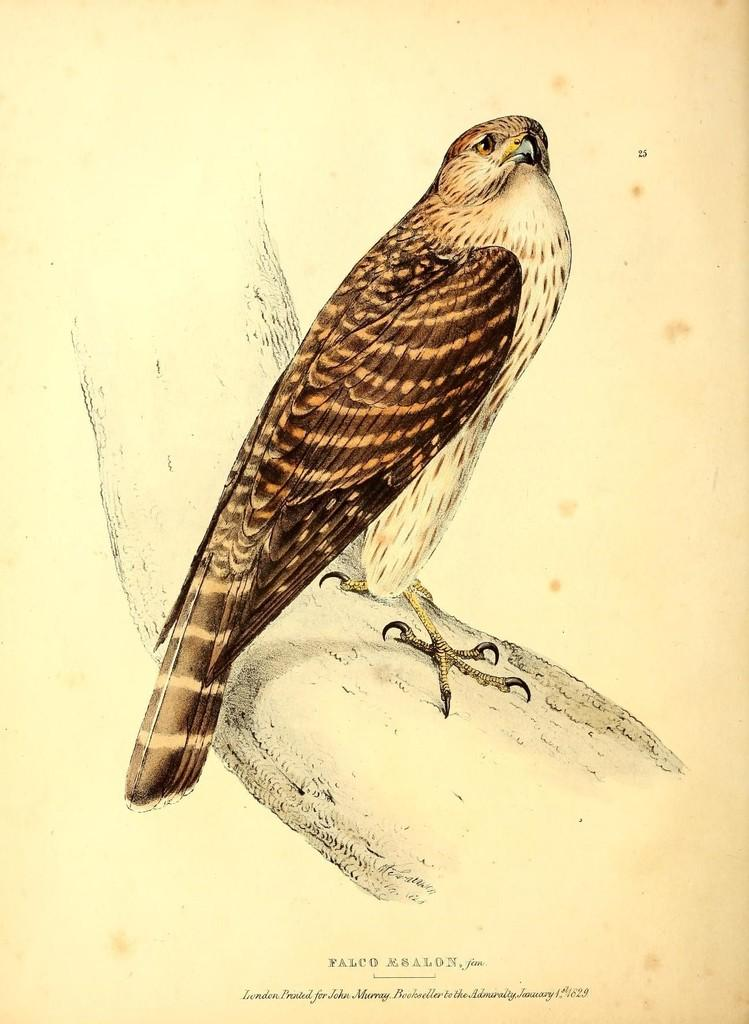What is featured in the image? There is a poster in the image. What is depicted on the poster? There is a bird in the center of the poster. What is the bird doing on the poster? The bird is standing on a tree branch. What additional information is provided on the poster? There is a quotation at the bottom of the poster. What type of coal is being sold in the shop depicted on the poster? There is no shop or coal present in the image; it features a poster with a bird on a tree branch and a quotation. 